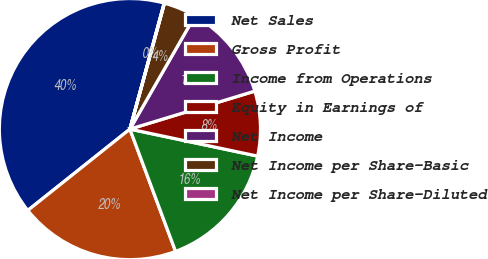Convert chart. <chart><loc_0><loc_0><loc_500><loc_500><pie_chart><fcel>Net Sales<fcel>Gross Profit<fcel>Income from Operations<fcel>Equity in Earnings of<fcel>Net Income<fcel>Net Income per Share-Basic<fcel>Net Income per Share-Diluted<nl><fcel>39.94%<fcel>19.99%<fcel>16.0%<fcel>8.02%<fcel>12.01%<fcel>4.03%<fcel>0.04%<nl></chart> 